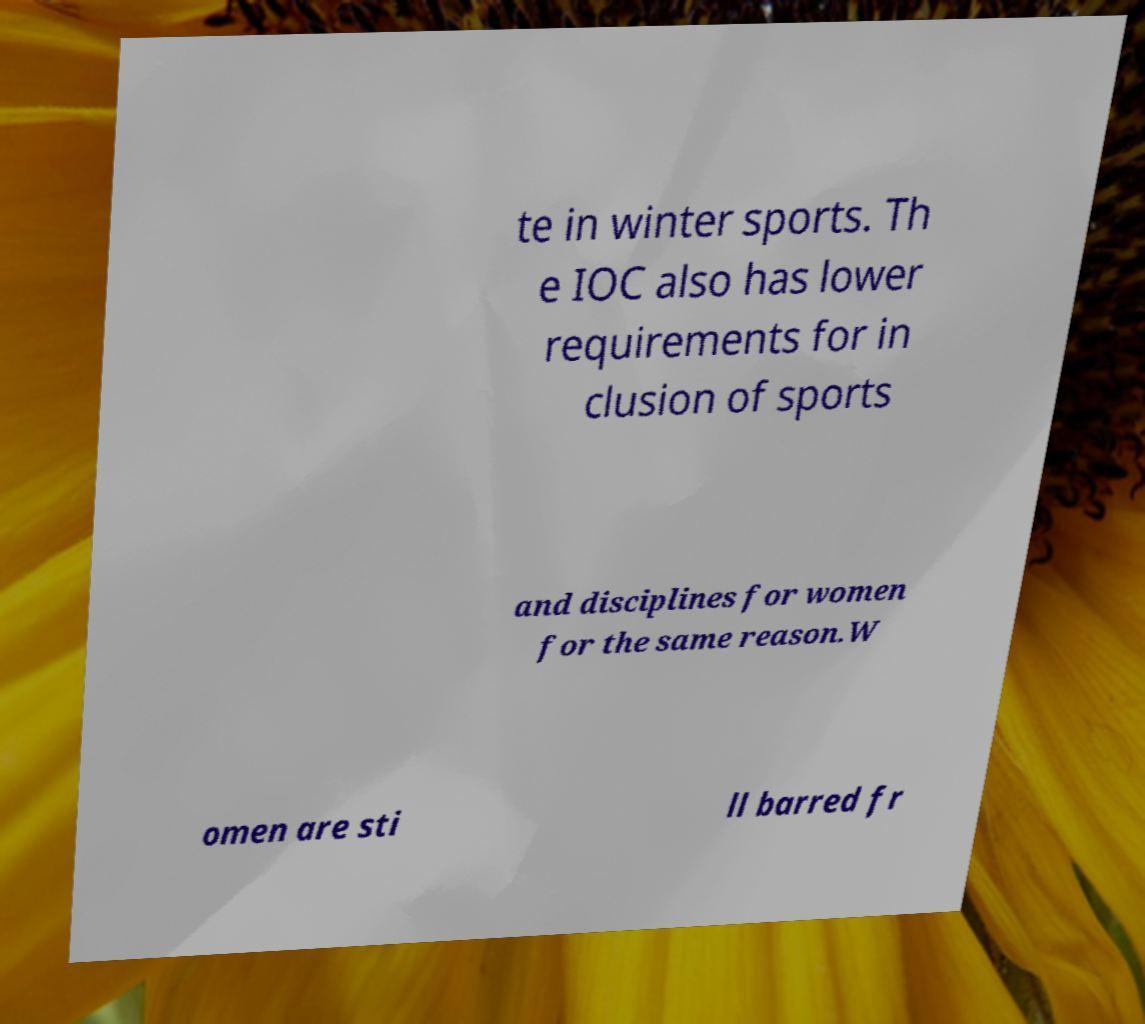Could you assist in decoding the text presented in this image and type it out clearly? te in winter sports. Th e IOC also has lower requirements for in clusion of sports and disciplines for women for the same reason.W omen are sti ll barred fr 